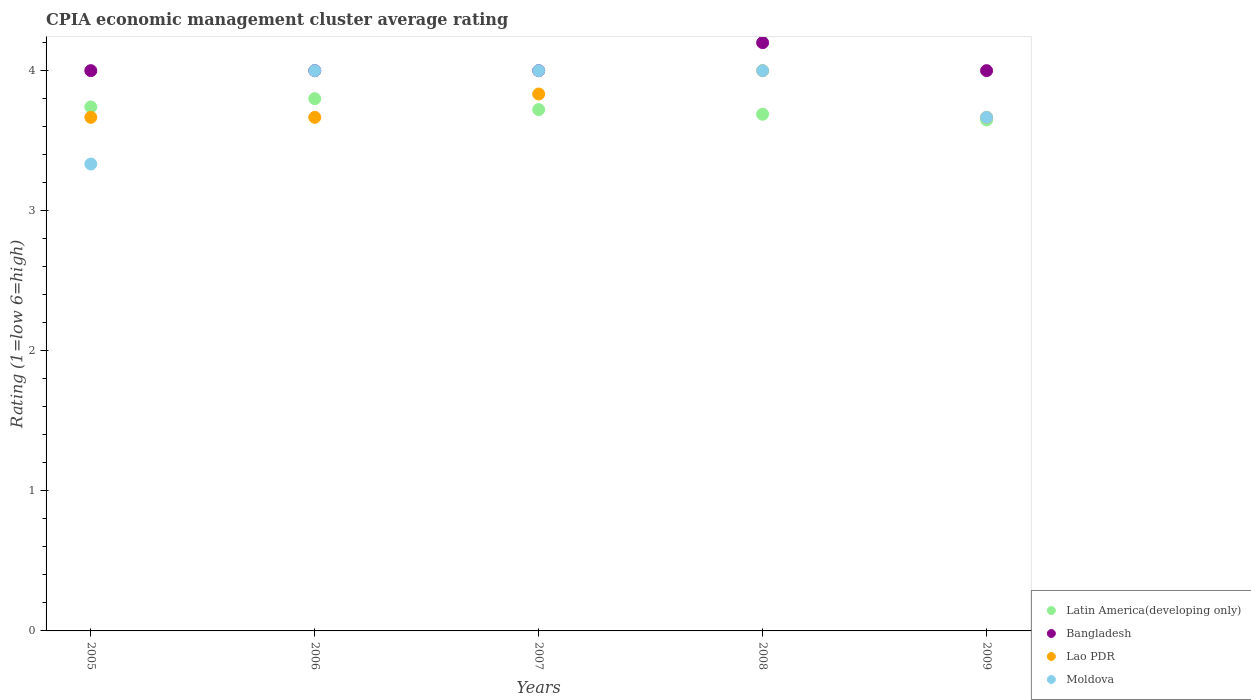How many different coloured dotlines are there?
Your answer should be very brief. 4. Is the number of dotlines equal to the number of legend labels?
Give a very brief answer. Yes. What is the CPIA rating in Latin America(developing only) in 2005?
Offer a terse response. 3.74. Across all years, what is the minimum CPIA rating in Bangladesh?
Offer a very short reply. 4. In which year was the CPIA rating in Lao PDR minimum?
Offer a very short reply. 2005. What is the total CPIA rating in Lao PDR in the graph?
Offer a very short reply. 18.83. What is the difference between the CPIA rating in Latin America(developing only) in 2005 and that in 2006?
Give a very brief answer. -0.06. What is the difference between the CPIA rating in Bangladesh in 2006 and the CPIA rating in Latin America(developing only) in 2009?
Your answer should be compact. 0.35. What is the average CPIA rating in Bangladesh per year?
Provide a short and direct response. 4.04. In the year 2006, what is the difference between the CPIA rating in Lao PDR and CPIA rating in Latin America(developing only)?
Provide a short and direct response. -0.13. In how many years, is the CPIA rating in Moldova greater than 1?
Keep it short and to the point. 5. What is the ratio of the CPIA rating in Bangladesh in 2007 to that in 2008?
Your response must be concise. 0.95. Is the CPIA rating in Latin America(developing only) in 2006 less than that in 2008?
Offer a very short reply. No. Is the difference between the CPIA rating in Lao PDR in 2005 and 2007 greater than the difference between the CPIA rating in Latin America(developing only) in 2005 and 2007?
Keep it short and to the point. No. What is the difference between the highest and the second highest CPIA rating in Latin America(developing only)?
Provide a succinct answer. 0.06. What is the difference between the highest and the lowest CPIA rating in Latin America(developing only)?
Provide a short and direct response. 0.15. Is it the case that in every year, the sum of the CPIA rating in Moldova and CPIA rating in Bangladesh  is greater than the sum of CPIA rating in Lao PDR and CPIA rating in Latin America(developing only)?
Provide a short and direct response. No. Is it the case that in every year, the sum of the CPIA rating in Lao PDR and CPIA rating in Latin America(developing only)  is greater than the CPIA rating in Bangladesh?
Provide a succinct answer. Yes. Is the CPIA rating in Bangladesh strictly less than the CPIA rating in Lao PDR over the years?
Your answer should be compact. No. Are the values on the major ticks of Y-axis written in scientific E-notation?
Offer a very short reply. No. Does the graph contain any zero values?
Your response must be concise. No. Where does the legend appear in the graph?
Provide a short and direct response. Bottom right. How are the legend labels stacked?
Keep it short and to the point. Vertical. What is the title of the graph?
Provide a succinct answer. CPIA economic management cluster average rating. What is the label or title of the Y-axis?
Keep it short and to the point. Rating (1=low 6=high). What is the Rating (1=low 6=high) of Latin America(developing only) in 2005?
Your answer should be very brief. 3.74. What is the Rating (1=low 6=high) of Lao PDR in 2005?
Your answer should be compact. 3.67. What is the Rating (1=low 6=high) of Moldova in 2005?
Provide a succinct answer. 3.33. What is the Rating (1=low 6=high) in Latin America(developing only) in 2006?
Offer a very short reply. 3.8. What is the Rating (1=low 6=high) of Bangladesh in 2006?
Make the answer very short. 4. What is the Rating (1=low 6=high) of Lao PDR in 2006?
Give a very brief answer. 3.67. What is the Rating (1=low 6=high) in Moldova in 2006?
Offer a terse response. 4. What is the Rating (1=low 6=high) of Latin America(developing only) in 2007?
Ensure brevity in your answer.  3.72. What is the Rating (1=low 6=high) in Lao PDR in 2007?
Your answer should be compact. 3.83. What is the Rating (1=low 6=high) of Moldova in 2007?
Your answer should be very brief. 4. What is the Rating (1=low 6=high) of Latin America(developing only) in 2008?
Give a very brief answer. 3.69. What is the Rating (1=low 6=high) of Moldova in 2008?
Provide a succinct answer. 4. What is the Rating (1=low 6=high) in Latin America(developing only) in 2009?
Ensure brevity in your answer.  3.65. What is the Rating (1=low 6=high) of Lao PDR in 2009?
Provide a short and direct response. 3.67. What is the Rating (1=low 6=high) of Moldova in 2009?
Keep it short and to the point. 3.67. Across all years, what is the maximum Rating (1=low 6=high) of Latin America(developing only)?
Your answer should be compact. 3.8. Across all years, what is the maximum Rating (1=low 6=high) in Bangladesh?
Ensure brevity in your answer.  4.2. Across all years, what is the maximum Rating (1=low 6=high) in Lao PDR?
Provide a succinct answer. 4. Across all years, what is the maximum Rating (1=low 6=high) of Moldova?
Your response must be concise. 4. Across all years, what is the minimum Rating (1=low 6=high) in Latin America(developing only)?
Your response must be concise. 3.65. Across all years, what is the minimum Rating (1=low 6=high) of Lao PDR?
Ensure brevity in your answer.  3.67. Across all years, what is the minimum Rating (1=low 6=high) of Moldova?
Provide a short and direct response. 3.33. What is the total Rating (1=low 6=high) in Bangladesh in the graph?
Your answer should be compact. 20.2. What is the total Rating (1=low 6=high) of Lao PDR in the graph?
Provide a short and direct response. 18.83. What is the difference between the Rating (1=low 6=high) of Latin America(developing only) in 2005 and that in 2006?
Your response must be concise. -0.06. What is the difference between the Rating (1=low 6=high) of Lao PDR in 2005 and that in 2006?
Your response must be concise. 0. What is the difference between the Rating (1=low 6=high) of Latin America(developing only) in 2005 and that in 2007?
Your answer should be compact. 0.02. What is the difference between the Rating (1=low 6=high) in Moldova in 2005 and that in 2007?
Ensure brevity in your answer.  -0.67. What is the difference between the Rating (1=low 6=high) of Latin America(developing only) in 2005 and that in 2008?
Give a very brief answer. 0.05. What is the difference between the Rating (1=low 6=high) in Bangladesh in 2005 and that in 2008?
Keep it short and to the point. -0.2. What is the difference between the Rating (1=low 6=high) in Lao PDR in 2005 and that in 2008?
Your answer should be compact. -0.33. What is the difference between the Rating (1=low 6=high) in Moldova in 2005 and that in 2008?
Give a very brief answer. -0.67. What is the difference between the Rating (1=low 6=high) in Latin America(developing only) in 2005 and that in 2009?
Offer a very short reply. 0.09. What is the difference between the Rating (1=low 6=high) in Bangladesh in 2005 and that in 2009?
Your response must be concise. 0. What is the difference between the Rating (1=low 6=high) in Moldova in 2005 and that in 2009?
Keep it short and to the point. -0.33. What is the difference between the Rating (1=low 6=high) in Latin America(developing only) in 2006 and that in 2007?
Offer a terse response. 0.08. What is the difference between the Rating (1=low 6=high) of Bangladesh in 2006 and that in 2007?
Provide a succinct answer. 0. What is the difference between the Rating (1=low 6=high) of Moldova in 2006 and that in 2007?
Your answer should be very brief. 0. What is the difference between the Rating (1=low 6=high) in Bangladesh in 2006 and that in 2008?
Your answer should be compact. -0.2. What is the difference between the Rating (1=low 6=high) in Moldova in 2006 and that in 2008?
Ensure brevity in your answer.  0. What is the difference between the Rating (1=low 6=high) of Latin America(developing only) in 2006 and that in 2009?
Keep it short and to the point. 0.15. What is the difference between the Rating (1=low 6=high) in Bangladesh in 2006 and that in 2009?
Ensure brevity in your answer.  0. What is the difference between the Rating (1=low 6=high) of Lao PDR in 2006 and that in 2009?
Provide a short and direct response. 0. What is the difference between the Rating (1=low 6=high) of Latin America(developing only) in 2007 and that in 2008?
Ensure brevity in your answer.  0.03. What is the difference between the Rating (1=low 6=high) of Lao PDR in 2007 and that in 2008?
Provide a short and direct response. -0.17. What is the difference between the Rating (1=low 6=high) of Latin America(developing only) in 2007 and that in 2009?
Offer a terse response. 0.07. What is the difference between the Rating (1=low 6=high) in Moldova in 2007 and that in 2009?
Ensure brevity in your answer.  0.33. What is the difference between the Rating (1=low 6=high) in Latin America(developing only) in 2008 and that in 2009?
Make the answer very short. 0.04. What is the difference between the Rating (1=low 6=high) of Lao PDR in 2008 and that in 2009?
Offer a very short reply. 0.33. What is the difference between the Rating (1=low 6=high) of Latin America(developing only) in 2005 and the Rating (1=low 6=high) of Bangladesh in 2006?
Your answer should be very brief. -0.26. What is the difference between the Rating (1=low 6=high) in Latin America(developing only) in 2005 and the Rating (1=low 6=high) in Lao PDR in 2006?
Provide a short and direct response. 0.07. What is the difference between the Rating (1=low 6=high) in Latin America(developing only) in 2005 and the Rating (1=low 6=high) in Moldova in 2006?
Keep it short and to the point. -0.26. What is the difference between the Rating (1=low 6=high) of Bangladesh in 2005 and the Rating (1=low 6=high) of Moldova in 2006?
Make the answer very short. 0. What is the difference between the Rating (1=low 6=high) in Lao PDR in 2005 and the Rating (1=low 6=high) in Moldova in 2006?
Offer a very short reply. -0.33. What is the difference between the Rating (1=low 6=high) of Latin America(developing only) in 2005 and the Rating (1=low 6=high) of Bangladesh in 2007?
Ensure brevity in your answer.  -0.26. What is the difference between the Rating (1=low 6=high) of Latin America(developing only) in 2005 and the Rating (1=low 6=high) of Lao PDR in 2007?
Offer a terse response. -0.09. What is the difference between the Rating (1=low 6=high) of Latin America(developing only) in 2005 and the Rating (1=low 6=high) of Moldova in 2007?
Provide a succinct answer. -0.26. What is the difference between the Rating (1=low 6=high) of Latin America(developing only) in 2005 and the Rating (1=low 6=high) of Bangladesh in 2008?
Provide a short and direct response. -0.46. What is the difference between the Rating (1=low 6=high) in Latin America(developing only) in 2005 and the Rating (1=low 6=high) in Lao PDR in 2008?
Provide a short and direct response. -0.26. What is the difference between the Rating (1=low 6=high) in Latin America(developing only) in 2005 and the Rating (1=low 6=high) in Moldova in 2008?
Offer a very short reply. -0.26. What is the difference between the Rating (1=low 6=high) of Bangladesh in 2005 and the Rating (1=low 6=high) of Lao PDR in 2008?
Your response must be concise. 0. What is the difference between the Rating (1=low 6=high) of Bangladesh in 2005 and the Rating (1=low 6=high) of Moldova in 2008?
Your response must be concise. 0. What is the difference between the Rating (1=low 6=high) in Lao PDR in 2005 and the Rating (1=low 6=high) in Moldova in 2008?
Make the answer very short. -0.33. What is the difference between the Rating (1=low 6=high) of Latin America(developing only) in 2005 and the Rating (1=low 6=high) of Bangladesh in 2009?
Provide a short and direct response. -0.26. What is the difference between the Rating (1=low 6=high) in Latin America(developing only) in 2005 and the Rating (1=low 6=high) in Lao PDR in 2009?
Ensure brevity in your answer.  0.07. What is the difference between the Rating (1=low 6=high) of Latin America(developing only) in 2005 and the Rating (1=low 6=high) of Moldova in 2009?
Your answer should be compact. 0.07. What is the difference between the Rating (1=low 6=high) in Latin America(developing only) in 2006 and the Rating (1=low 6=high) in Lao PDR in 2007?
Your answer should be very brief. -0.03. What is the difference between the Rating (1=low 6=high) of Latin America(developing only) in 2006 and the Rating (1=low 6=high) of Moldova in 2007?
Your answer should be compact. -0.2. What is the difference between the Rating (1=low 6=high) in Bangladesh in 2006 and the Rating (1=low 6=high) in Lao PDR in 2007?
Make the answer very short. 0.17. What is the difference between the Rating (1=low 6=high) of Bangladesh in 2006 and the Rating (1=low 6=high) of Moldova in 2007?
Keep it short and to the point. 0. What is the difference between the Rating (1=low 6=high) in Lao PDR in 2006 and the Rating (1=low 6=high) in Moldova in 2007?
Keep it short and to the point. -0.33. What is the difference between the Rating (1=low 6=high) in Latin America(developing only) in 2006 and the Rating (1=low 6=high) in Bangladesh in 2008?
Your response must be concise. -0.4. What is the difference between the Rating (1=low 6=high) in Latin America(developing only) in 2006 and the Rating (1=low 6=high) in Lao PDR in 2008?
Your answer should be compact. -0.2. What is the difference between the Rating (1=low 6=high) of Latin America(developing only) in 2006 and the Rating (1=low 6=high) of Moldova in 2008?
Keep it short and to the point. -0.2. What is the difference between the Rating (1=low 6=high) of Lao PDR in 2006 and the Rating (1=low 6=high) of Moldova in 2008?
Make the answer very short. -0.33. What is the difference between the Rating (1=low 6=high) of Latin America(developing only) in 2006 and the Rating (1=low 6=high) of Lao PDR in 2009?
Keep it short and to the point. 0.13. What is the difference between the Rating (1=low 6=high) of Latin America(developing only) in 2006 and the Rating (1=low 6=high) of Moldova in 2009?
Make the answer very short. 0.13. What is the difference between the Rating (1=low 6=high) of Bangladesh in 2006 and the Rating (1=low 6=high) of Lao PDR in 2009?
Your answer should be very brief. 0.33. What is the difference between the Rating (1=low 6=high) in Bangladesh in 2006 and the Rating (1=low 6=high) in Moldova in 2009?
Your answer should be very brief. 0.33. What is the difference between the Rating (1=low 6=high) of Latin America(developing only) in 2007 and the Rating (1=low 6=high) of Bangladesh in 2008?
Offer a very short reply. -0.48. What is the difference between the Rating (1=low 6=high) in Latin America(developing only) in 2007 and the Rating (1=low 6=high) in Lao PDR in 2008?
Your answer should be very brief. -0.28. What is the difference between the Rating (1=low 6=high) of Latin America(developing only) in 2007 and the Rating (1=low 6=high) of Moldova in 2008?
Provide a succinct answer. -0.28. What is the difference between the Rating (1=low 6=high) of Bangladesh in 2007 and the Rating (1=low 6=high) of Moldova in 2008?
Provide a short and direct response. 0. What is the difference between the Rating (1=low 6=high) of Lao PDR in 2007 and the Rating (1=low 6=high) of Moldova in 2008?
Ensure brevity in your answer.  -0.17. What is the difference between the Rating (1=low 6=high) of Latin America(developing only) in 2007 and the Rating (1=low 6=high) of Bangladesh in 2009?
Provide a succinct answer. -0.28. What is the difference between the Rating (1=low 6=high) of Latin America(developing only) in 2007 and the Rating (1=low 6=high) of Lao PDR in 2009?
Ensure brevity in your answer.  0.06. What is the difference between the Rating (1=low 6=high) of Latin America(developing only) in 2007 and the Rating (1=low 6=high) of Moldova in 2009?
Your response must be concise. 0.06. What is the difference between the Rating (1=low 6=high) in Lao PDR in 2007 and the Rating (1=low 6=high) in Moldova in 2009?
Make the answer very short. 0.17. What is the difference between the Rating (1=low 6=high) of Latin America(developing only) in 2008 and the Rating (1=low 6=high) of Bangladesh in 2009?
Your answer should be very brief. -0.31. What is the difference between the Rating (1=low 6=high) of Latin America(developing only) in 2008 and the Rating (1=low 6=high) of Lao PDR in 2009?
Provide a succinct answer. 0.02. What is the difference between the Rating (1=low 6=high) of Latin America(developing only) in 2008 and the Rating (1=low 6=high) of Moldova in 2009?
Give a very brief answer. 0.02. What is the difference between the Rating (1=low 6=high) of Bangladesh in 2008 and the Rating (1=low 6=high) of Lao PDR in 2009?
Provide a succinct answer. 0.53. What is the difference between the Rating (1=low 6=high) of Bangladesh in 2008 and the Rating (1=low 6=high) of Moldova in 2009?
Keep it short and to the point. 0.53. What is the difference between the Rating (1=low 6=high) in Lao PDR in 2008 and the Rating (1=low 6=high) in Moldova in 2009?
Offer a terse response. 0.33. What is the average Rating (1=low 6=high) of Latin America(developing only) per year?
Give a very brief answer. 3.72. What is the average Rating (1=low 6=high) in Bangladesh per year?
Offer a terse response. 4.04. What is the average Rating (1=low 6=high) in Lao PDR per year?
Provide a short and direct response. 3.77. In the year 2005, what is the difference between the Rating (1=low 6=high) of Latin America(developing only) and Rating (1=low 6=high) of Bangladesh?
Your answer should be compact. -0.26. In the year 2005, what is the difference between the Rating (1=low 6=high) of Latin America(developing only) and Rating (1=low 6=high) of Lao PDR?
Your answer should be compact. 0.07. In the year 2005, what is the difference between the Rating (1=low 6=high) of Latin America(developing only) and Rating (1=low 6=high) of Moldova?
Keep it short and to the point. 0.41. In the year 2005, what is the difference between the Rating (1=low 6=high) in Bangladesh and Rating (1=low 6=high) in Moldova?
Keep it short and to the point. 0.67. In the year 2005, what is the difference between the Rating (1=low 6=high) of Lao PDR and Rating (1=low 6=high) of Moldova?
Ensure brevity in your answer.  0.33. In the year 2006, what is the difference between the Rating (1=low 6=high) of Latin America(developing only) and Rating (1=low 6=high) of Bangladesh?
Provide a succinct answer. -0.2. In the year 2006, what is the difference between the Rating (1=low 6=high) in Latin America(developing only) and Rating (1=low 6=high) in Lao PDR?
Your response must be concise. 0.13. In the year 2006, what is the difference between the Rating (1=low 6=high) of Bangladesh and Rating (1=low 6=high) of Lao PDR?
Give a very brief answer. 0.33. In the year 2006, what is the difference between the Rating (1=low 6=high) in Bangladesh and Rating (1=low 6=high) in Moldova?
Offer a terse response. 0. In the year 2007, what is the difference between the Rating (1=low 6=high) of Latin America(developing only) and Rating (1=low 6=high) of Bangladesh?
Your answer should be compact. -0.28. In the year 2007, what is the difference between the Rating (1=low 6=high) in Latin America(developing only) and Rating (1=low 6=high) in Lao PDR?
Provide a short and direct response. -0.11. In the year 2007, what is the difference between the Rating (1=low 6=high) in Latin America(developing only) and Rating (1=low 6=high) in Moldova?
Make the answer very short. -0.28. In the year 2007, what is the difference between the Rating (1=low 6=high) in Lao PDR and Rating (1=low 6=high) in Moldova?
Provide a short and direct response. -0.17. In the year 2008, what is the difference between the Rating (1=low 6=high) in Latin America(developing only) and Rating (1=low 6=high) in Bangladesh?
Keep it short and to the point. -0.51. In the year 2008, what is the difference between the Rating (1=low 6=high) in Latin America(developing only) and Rating (1=low 6=high) in Lao PDR?
Offer a terse response. -0.31. In the year 2008, what is the difference between the Rating (1=low 6=high) of Latin America(developing only) and Rating (1=low 6=high) of Moldova?
Provide a succinct answer. -0.31. In the year 2008, what is the difference between the Rating (1=low 6=high) of Bangladesh and Rating (1=low 6=high) of Lao PDR?
Provide a short and direct response. 0.2. In the year 2008, what is the difference between the Rating (1=low 6=high) in Bangladesh and Rating (1=low 6=high) in Moldova?
Offer a very short reply. 0.2. In the year 2009, what is the difference between the Rating (1=low 6=high) in Latin America(developing only) and Rating (1=low 6=high) in Bangladesh?
Make the answer very short. -0.35. In the year 2009, what is the difference between the Rating (1=low 6=high) in Latin America(developing only) and Rating (1=low 6=high) in Lao PDR?
Keep it short and to the point. -0.02. In the year 2009, what is the difference between the Rating (1=low 6=high) of Latin America(developing only) and Rating (1=low 6=high) of Moldova?
Offer a terse response. -0.02. In the year 2009, what is the difference between the Rating (1=low 6=high) in Lao PDR and Rating (1=low 6=high) in Moldova?
Offer a very short reply. 0. What is the ratio of the Rating (1=low 6=high) of Latin America(developing only) in 2005 to that in 2006?
Keep it short and to the point. 0.98. What is the ratio of the Rating (1=low 6=high) of Moldova in 2005 to that in 2006?
Your answer should be compact. 0.83. What is the ratio of the Rating (1=low 6=high) of Lao PDR in 2005 to that in 2007?
Your response must be concise. 0.96. What is the ratio of the Rating (1=low 6=high) in Latin America(developing only) in 2005 to that in 2008?
Your response must be concise. 1.01. What is the ratio of the Rating (1=low 6=high) of Bangladesh in 2005 to that in 2008?
Offer a terse response. 0.95. What is the ratio of the Rating (1=low 6=high) of Moldova in 2005 to that in 2008?
Provide a short and direct response. 0.83. What is the ratio of the Rating (1=low 6=high) in Latin America(developing only) in 2005 to that in 2009?
Your answer should be compact. 1.03. What is the ratio of the Rating (1=low 6=high) in Bangladesh in 2005 to that in 2009?
Give a very brief answer. 1. What is the ratio of the Rating (1=low 6=high) of Moldova in 2005 to that in 2009?
Ensure brevity in your answer.  0.91. What is the ratio of the Rating (1=low 6=high) in Latin America(developing only) in 2006 to that in 2007?
Give a very brief answer. 1.02. What is the ratio of the Rating (1=low 6=high) in Lao PDR in 2006 to that in 2007?
Make the answer very short. 0.96. What is the ratio of the Rating (1=low 6=high) of Latin America(developing only) in 2006 to that in 2008?
Give a very brief answer. 1.03. What is the ratio of the Rating (1=low 6=high) of Latin America(developing only) in 2006 to that in 2009?
Provide a short and direct response. 1.04. What is the ratio of the Rating (1=low 6=high) of Bangladesh in 2006 to that in 2009?
Provide a short and direct response. 1. What is the ratio of the Rating (1=low 6=high) of Lao PDR in 2006 to that in 2009?
Make the answer very short. 1. What is the ratio of the Rating (1=low 6=high) of Moldova in 2006 to that in 2009?
Keep it short and to the point. 1.09. What is the ratio of the Rating (1=low 6=high) in Latin America(developing only) in 2007 to that in 2008?
Ensure brevity in your answer.  1.01. What is the ratio of the Rating (1=low 6=high) of Moldova in 2007 to that in 2008?
Your response must be concise. 1. What is the ratio of the Rating (1=low 6=high) in Latin America(developing only) in 2007 to that in 2009?
Ensure brevity in your answer.  1.02. What is the ratio of the Rating (1=low 6=high) of Bangladesh in 2007 to that in 2009?
Provide a succinct answer. 1. What is the ratio of the Rating (1=low 6=high) in Lao PDR in 2007 to that in 2009?
Provide a short and direct response. 1.05. What is the ratio of the Rating (1=low 6=high) of Moldova in 2007 to that in 2009?
Provide a short and direct response. 1.09. What is the ratio of the Rating (1=low 6=high) of Latin America(developing only) in 2008 to that in 2009?
Offer a very short reply. 1.01. What is the ratio of the Rating (1=low 6=high) of Bangladesh in 2008 to that in 2009?
Your answer should be very brief. 1.05. What is the difference between the highest and the second highest Rating (1=low 6=high) of Latin America(developing only)?
Provide a succinct answer. 0.06. What is the difference between the highest and the second highest Rating (1=low 6=high) of Bangladesh?
Your response must be concise. 0.2. What is the difference between the highest and the second highest Rating (1=low 6=high) in Moldova?
Provide a succinct answer. 0. What is the difference between the highest and the lowest Rating (1=low 6=high) in Latin America(developing only)?
Provide a short and direct response. 0.15. What is the difference between the highest and the lowest Rating (1=low 6=high) of Lao PDR?
Make the answer very short. 0.33. What is the difference between the highest and the lowest Rating (1=low 6=high) in Moldova?
Offer a terse response. 0.67. 